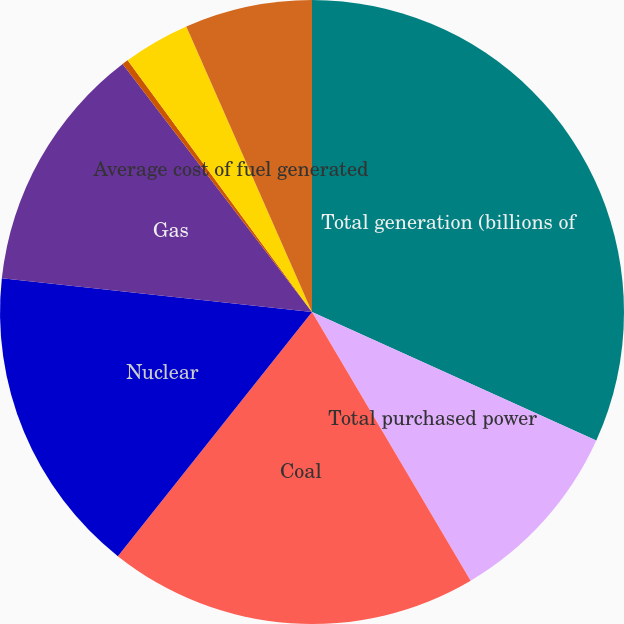<chart> <loc_0><loc_0><loc_500><loc_500><pie_chart><fcel>Total generation (billions of<fcel>Total purchased power<fcel>Coal<fcel>Nuclear<fcel>Gas<fcel>Hydro<fcel>Average cost of fuel generated<fcel>Average cost of purchased<nl><fcel>31.76%<fcel>9.75%<fcel>19.18%<fcel>16.04%<fcel>12.89%<fcel>0.32%<fcel>3.46%<fcel>6.6%<nl></chart> 